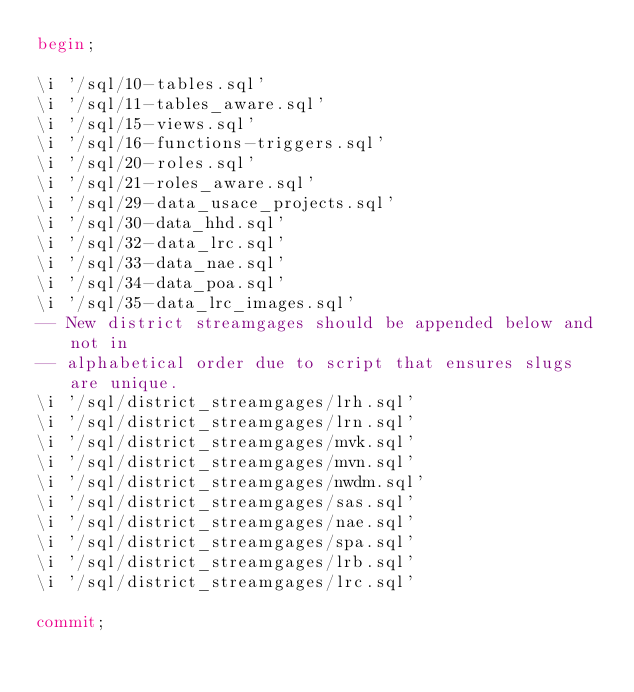Convert code to text. <code><loc_0><loc_0><loc_500><loc_500><_SQL_>begin;

\i '/sql/10-tables.sql'
\i '/sql/11-tables_aware.sql'
\i '/sql/15-views.sql'
\i '/sql/16-functions-triggers.sql'
\i '/sql/20-roles.sql'
\i '/sql/21-roles_aware.sql'
\i '/sql/29-data_usace_projects.sql'
\i '/sql/30-data_hhd.sql'
\i '/sql/32-data_lrc.sql'
\i '/sql/33-data_nae.sql'
\i '/sql/34-data_poa.sql'
\i '/sql/35-data_lrc_images.sql'
-- New district streamgages should be appended below and not in 
-- alphabetical order due to script that ensures slugs are unique.
\i '/sql/district_streamgages/lrh.sql'
\i '/sql/district_streamgages/lrn.sql'
\i '/sql/district_streamgages/mvk.sql'
\i '/sql/district_streamgages/mvn.sql'
\i '/sql/district_streamgages/nwdm.sql'
\i '/sql/district_streamgages/sas.sql'
\i '/sql/district_streamgages/nae.sql'
\i '/sql/district_streamgages/spa.sql'
\i '/sql/district_streamgages/lrb.sql'
\i '/sql/district_streamgages/lrc.sql'

commit;</code> 